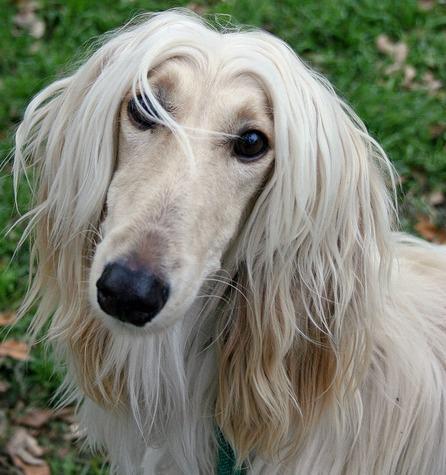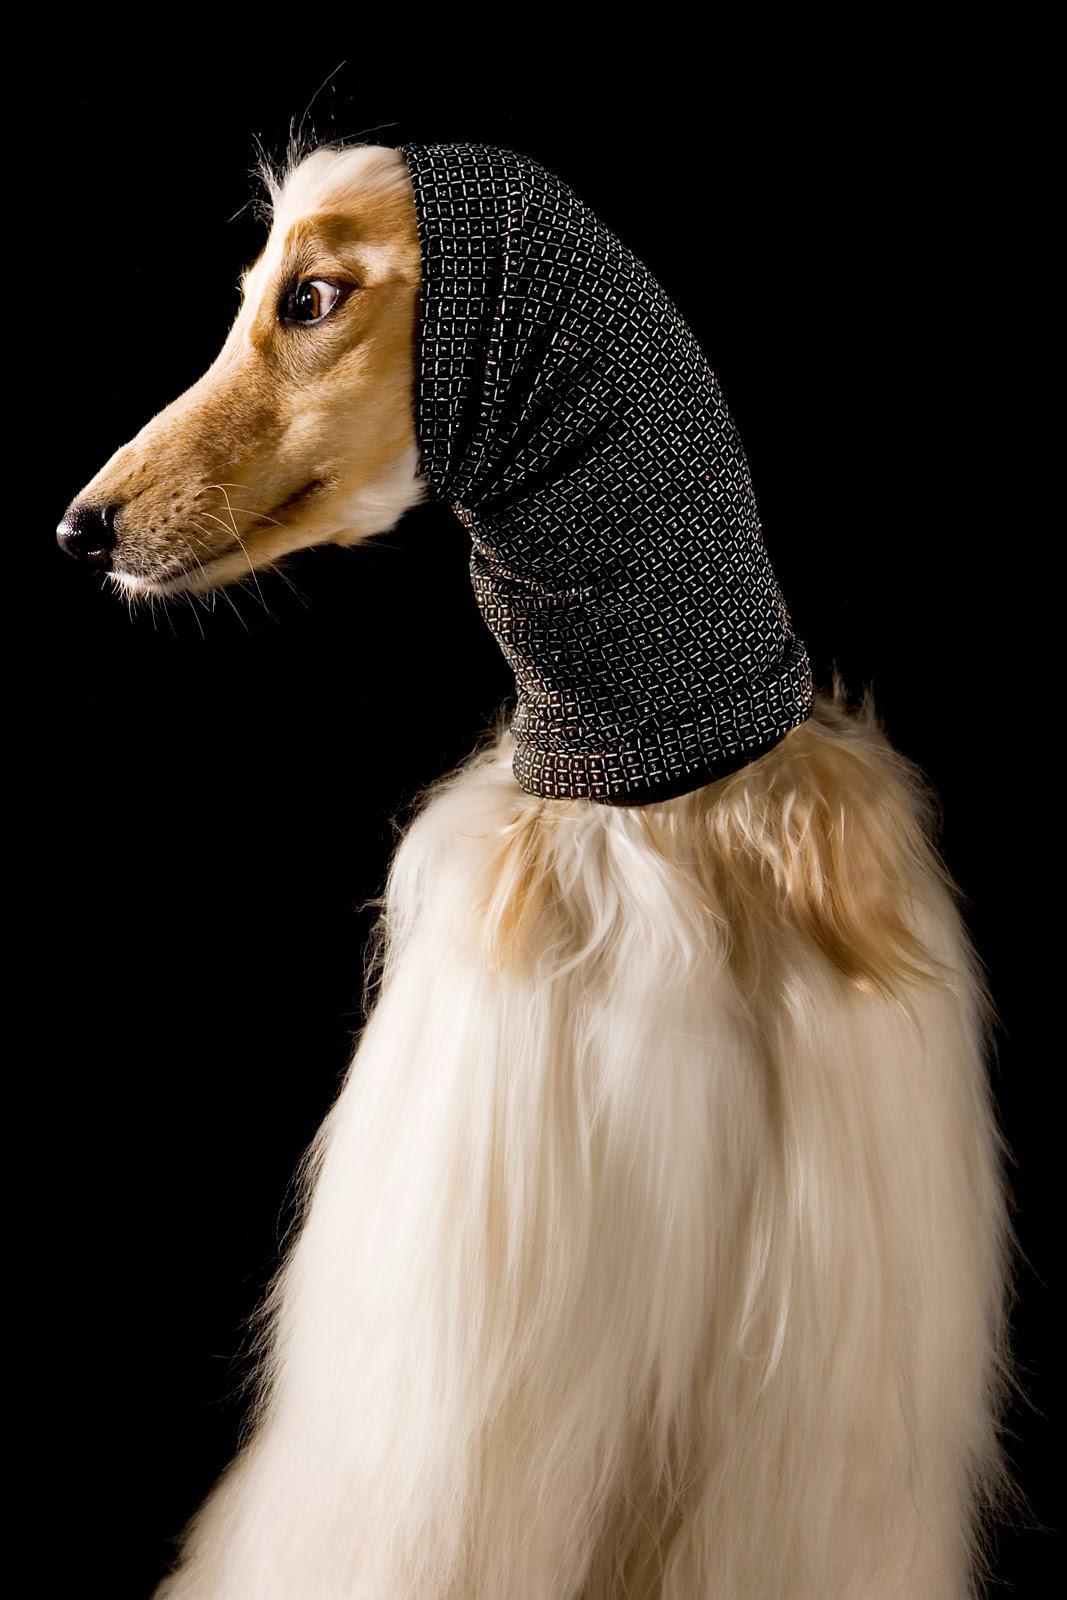The first image is the image on the left, the second image is the image on the right. Examine the images to the left and right. Is the description "Both images feature a dog wearing a head scarf." accurate? Answer yes or no. No. The first image is the image on the left, the second image is the image on the right. Examine the images to the left and right. Is the description "Each image shows an afghan hound wearing a wrap that covers its neck, ears and the top of its head." accurate? Answer yes or no. No. 